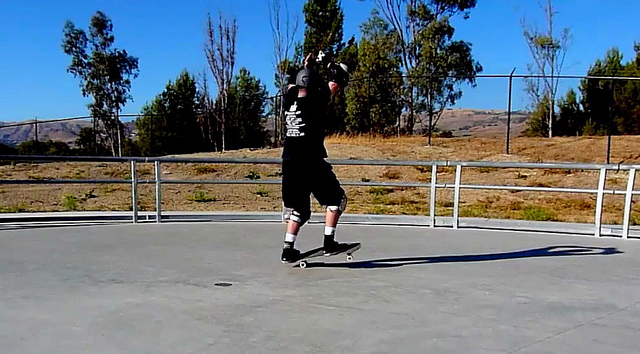What is the surface the man is skateboarding on made of? The man is skateboarding on what appears to be a concrete or cement surface. This material is common in skate parks and provides a smooth, durable foundation ideal for performing various skateboarding tricks. 